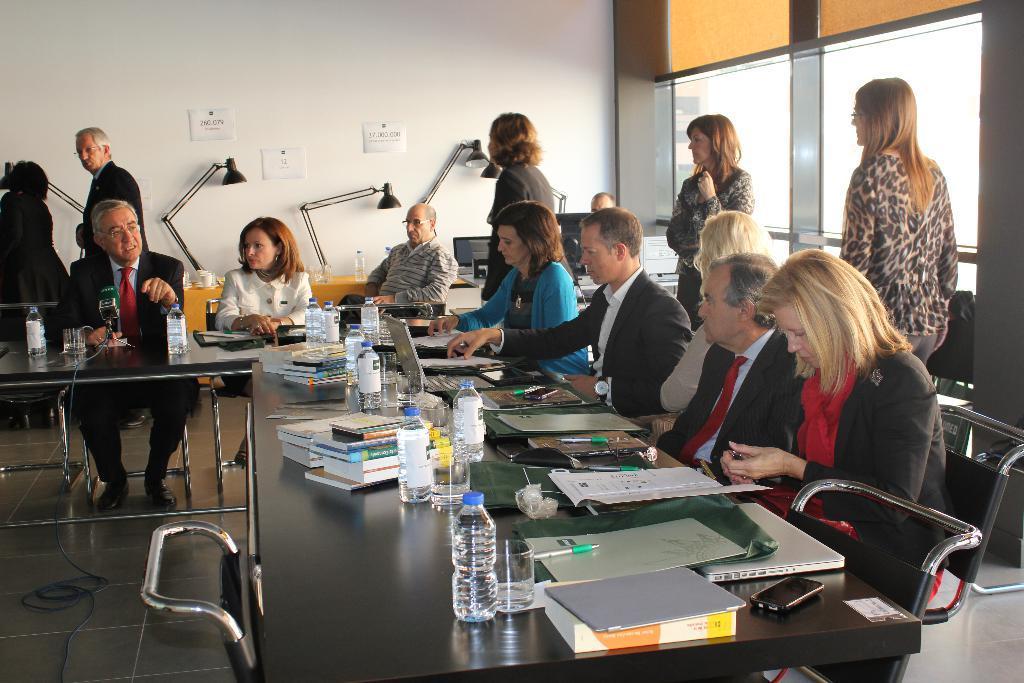Describe this image in one or two sentences. In a room there are few people and some of them are sitting around a table. On the table there are books, bottles, files, laptops and other objects and behind them there is a computer system and in the background there is a wall, in front of the wall there are lamps and on the right side there are windows. 